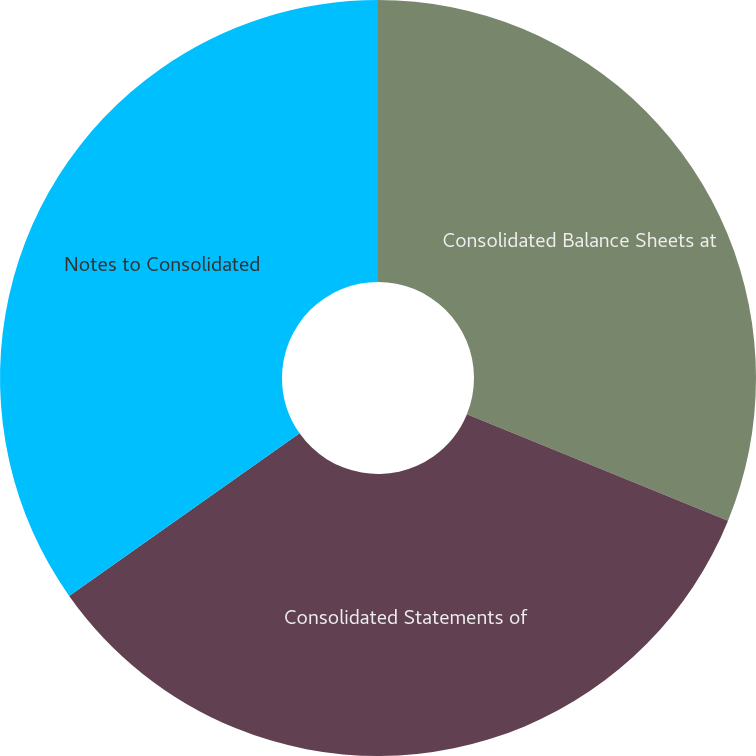<chart> <loc_0><loc_0><loc_500><loc_500><pie_chart><fcel>Consolidated Balance Sheets at<fcel>Consolidated Statements of<fcel>Notes to Consolidated<nl><fcel>31.16%<fcel>34.06%<fcel>34.78%<nl></chart> 